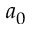<formula> <loc_0><loc_0><loc_500><loc_500>a _ { 0 }</formula> 